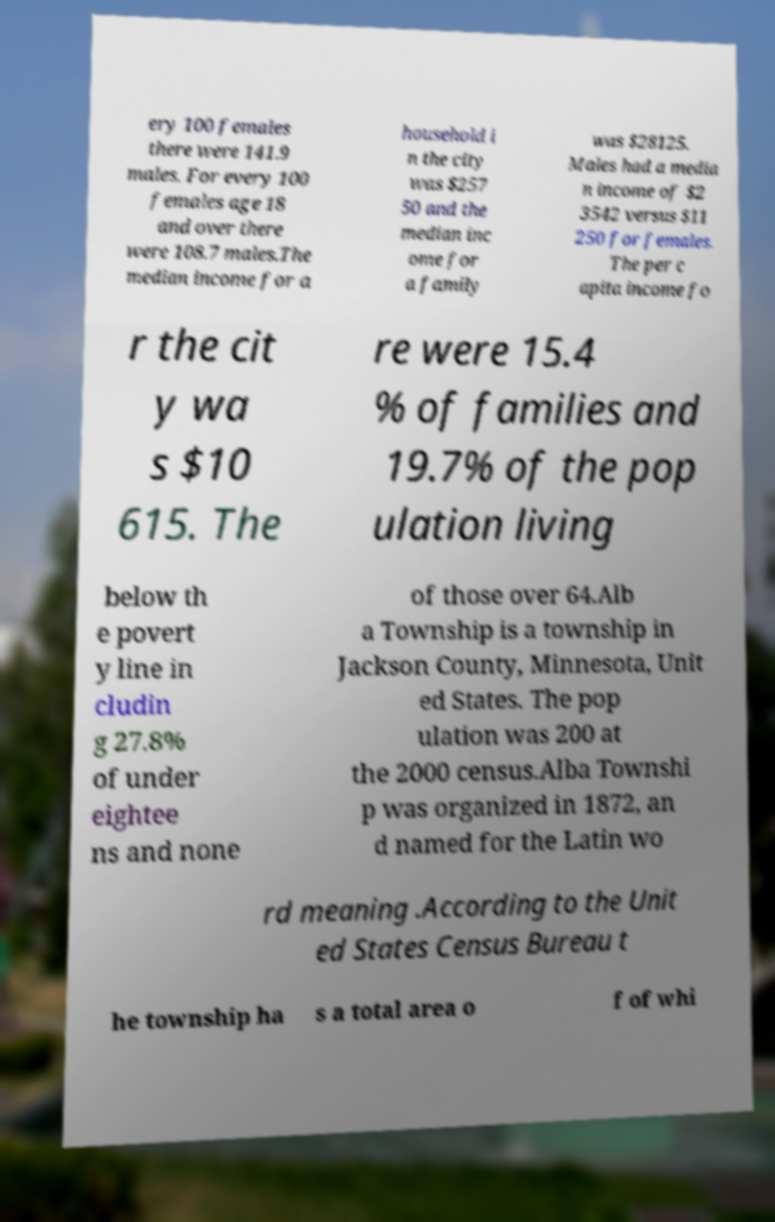What messages or text are displayed in this image? I need them in a readable, typed format. ery 100 females there were 141.9 males. For every 100 females age 18 and over there were 108.7 males.The median income for a household i n the city was $257 50 and the median inc ome for a family was $28125. Males had a media n income of $2 3542 versus $11 250 for females. The per c apita income fo r the cit y wa s $10 615. The re were 15.4 % of families and 19.7% of the pop ulation living below th e povert y line in cludin g 27.8% of under eightee ns and none of those over 64.Alb a Township is a township in Jackson County, Minnesota, Unit ed States. The pop ulation was 200 at the 2000 census.Alba Townshi p was organized in 1872, an d named for the Latin wo rd meaning .According to the Unit ed States Census Bureau t he township ha s a total area o f of whi 